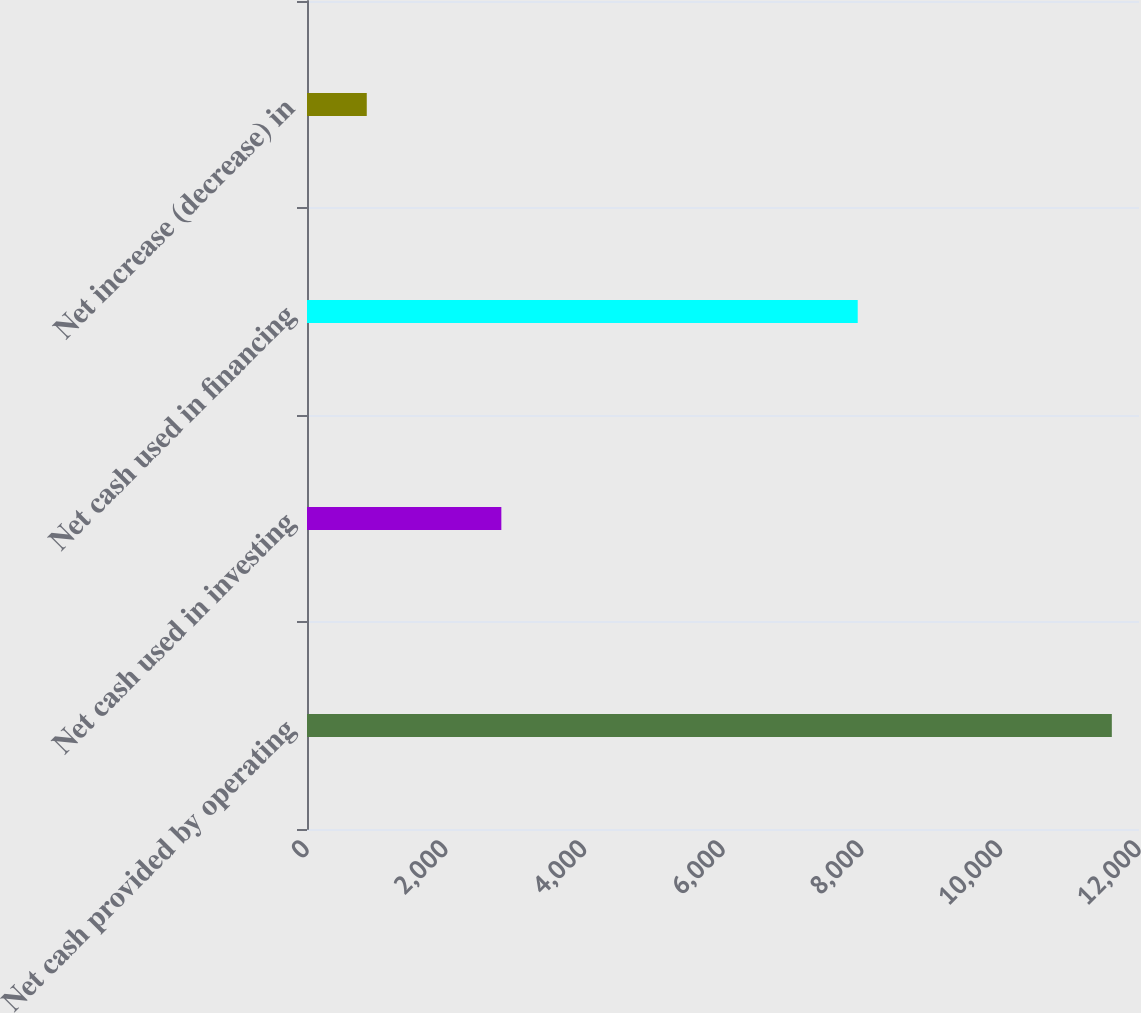Convert chart to OTSL. <chart><loc_0><loc_0><loc_500><loc_500><bar_chart><fcel>Net cash provided by operating<fcel>Net cash used in investing<fcel>Net cash used in financing<fcel>Net increase (decrease) in<nl><fcel>11608<fcel>2803<fcel>7943<fcel>862<nl></chart> 